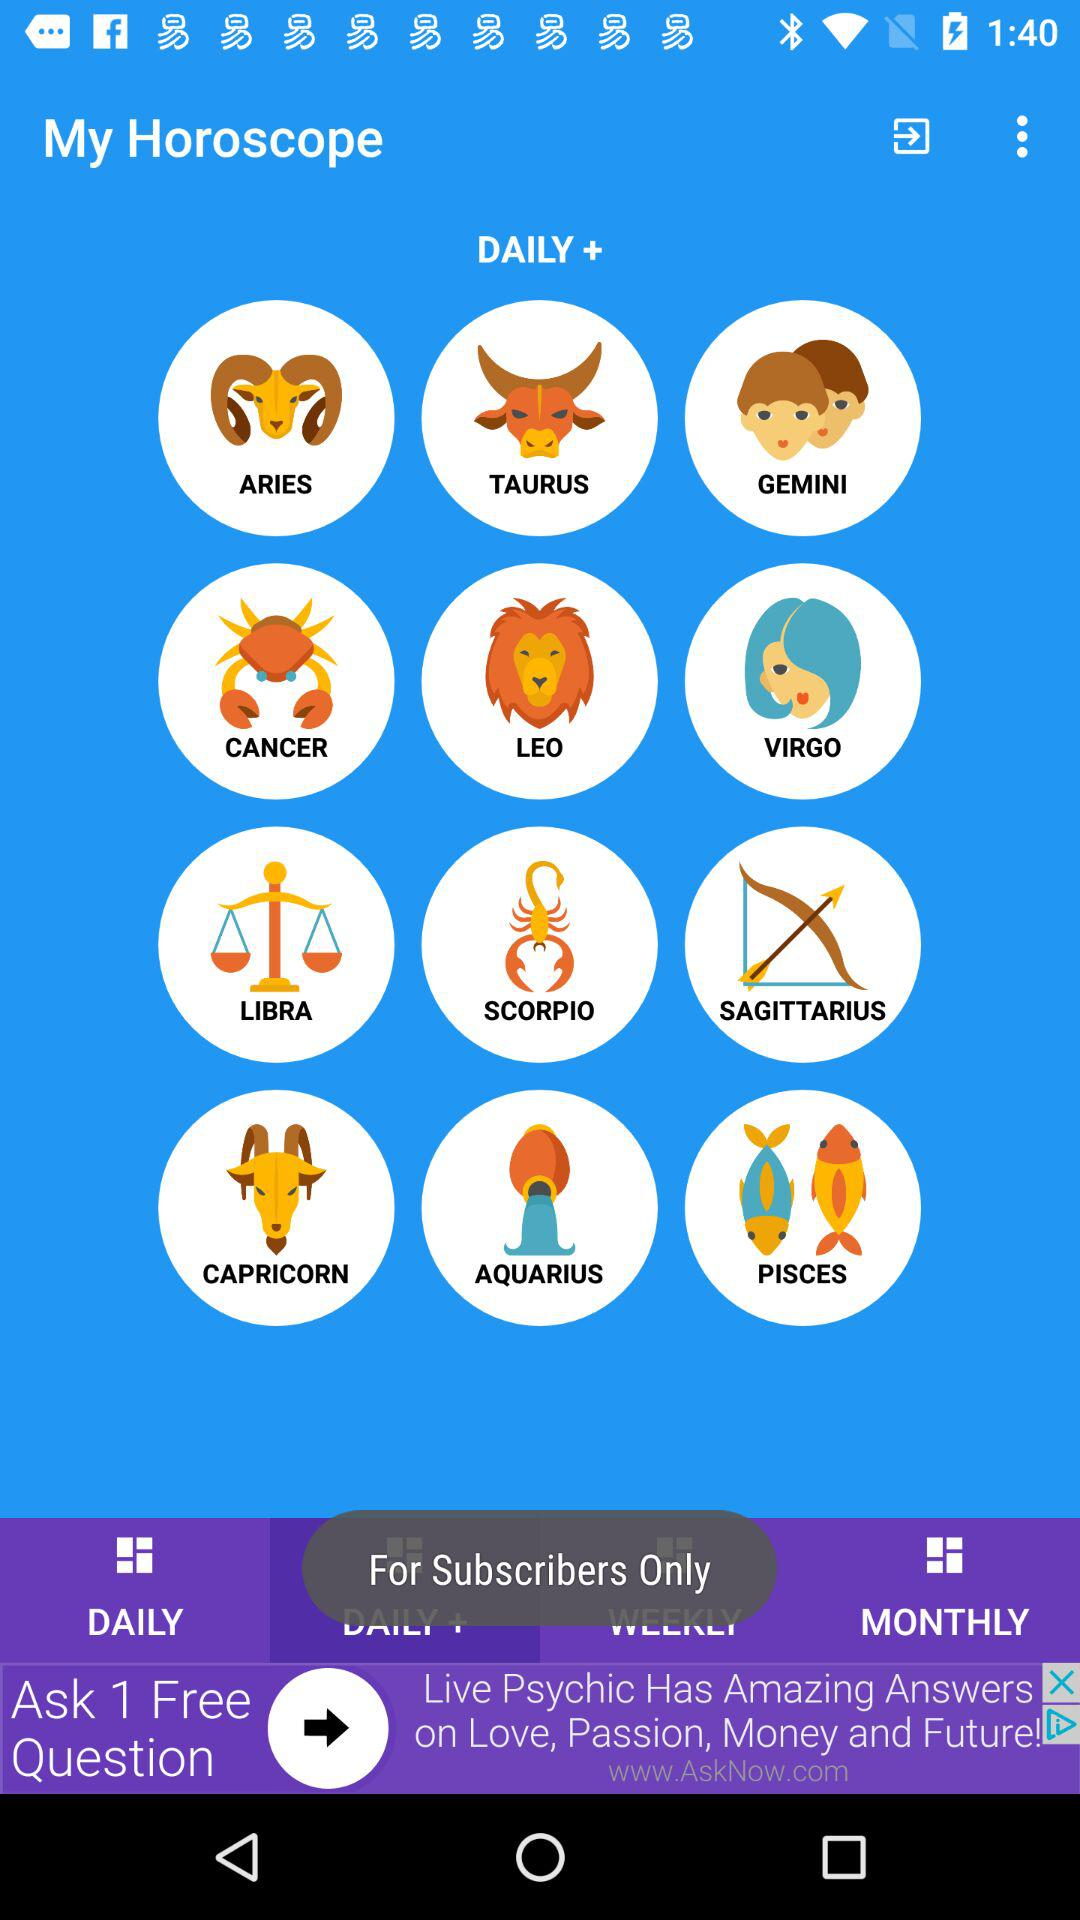What is the application name? The application name is "My Horoscope". 